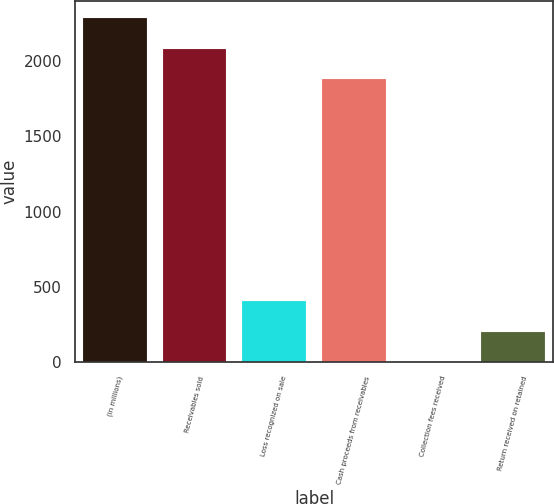Convert chart. <chart><loc_0><loc_0><loc_500><loc_500><bar_chart><fcel>(in millions)<fcel>Receivables sold<fcel>Loss recognized on sale<fcel>Cash proceeds from receivables<fcel>Collection fees received<fcel>Return received on retained<nl><fcel>2285<fcel>2083.5<fcel>404<fcel>1882<fcel>1<fcel>202.5<nl></chart> 